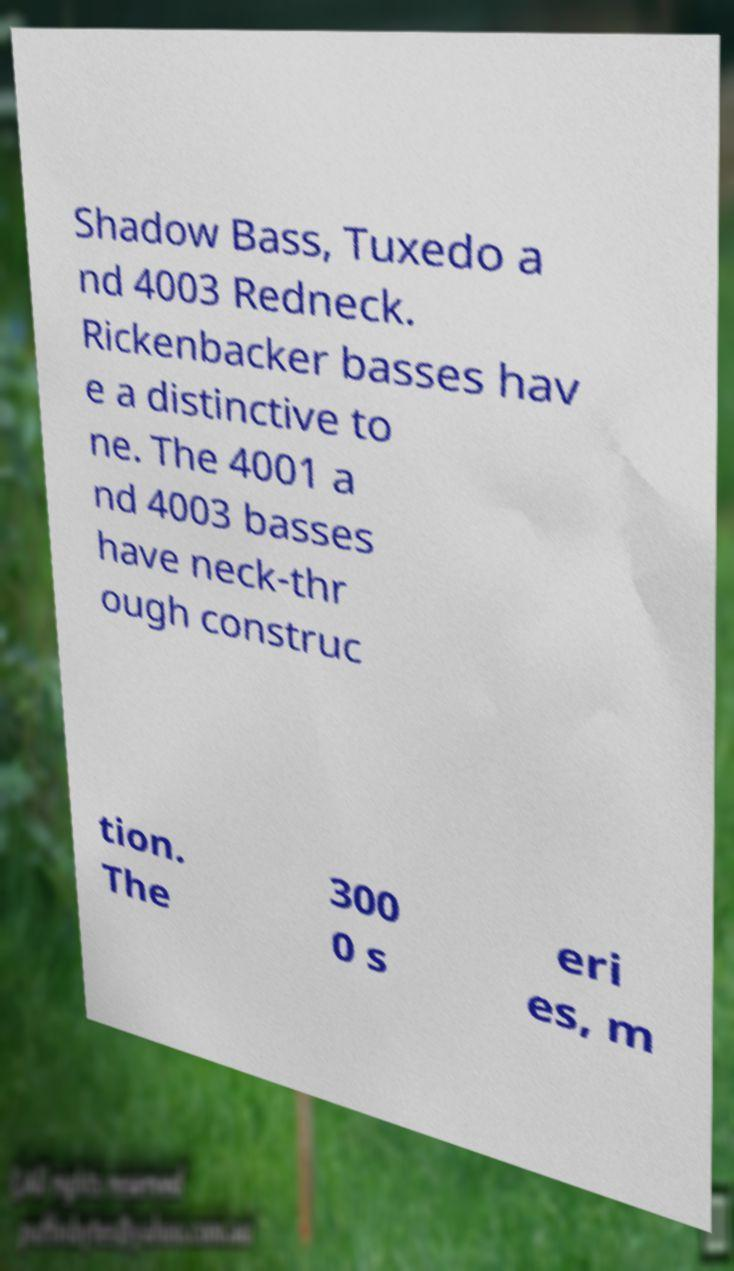Please identify and transcribe the text found in this image. Shadow Bass, Tuxedo a nd 4003 Redneck. Rickenbacker basses hav e a distinctive to ne. The 4001 a nd 4003 basses have neck-thr ough construc tion. The 300 0 s eri es, m 